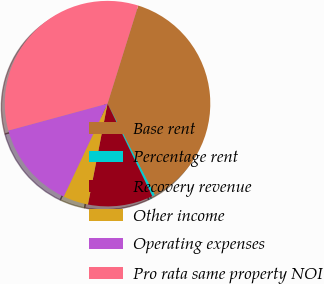Convert chart to OTSL. <chart><loc_0><loc_0><loc_500><loc_500><pie_chart><fcel>Base rent<fcel>Percentage rent<fcel>Recovery revenue<fcel>Other income<fcel>Operating expenses<fcel>Pro rata same property NOI<nl><fcel>37.59%<fcel>0.42%<fcel>10.22%<fcel>3.96%<fcel>13.76%<fcel>34.05%<nl></chart> 